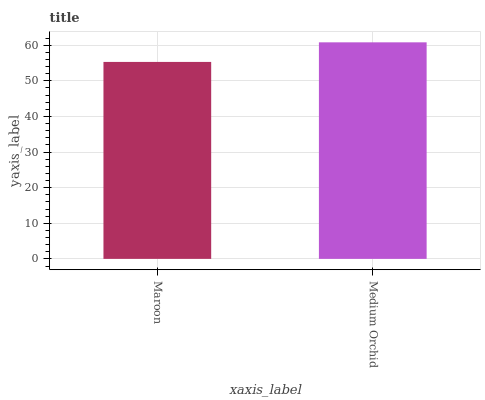Is Maroon the minimum?
Answer yes or no. Yes. Is Medium Orchid the maximum?
Answer yes or no. Yes. Is Medium Orchid the minimum?
Answer yes or no. No. Is Medium Orchid greater than Maroon?
Answer yes or no. Yes. Is Maroon less than Medium Orchid?
Answer yes or no. Yes. Is Maroon greater than Medium Orchid?
Answer yes or no. No. Is Medium Orchid less than Maroon?
Answer yes or no. No. Is Medium Orchid the high median?
Answer yes or no. Yes. Is Maroon the low median?
Answer yes or no. Yes. Is Maroon the high median?
Answer yes or no. No. Is Medium Orchid the low median?
Answer yes or no. No. 